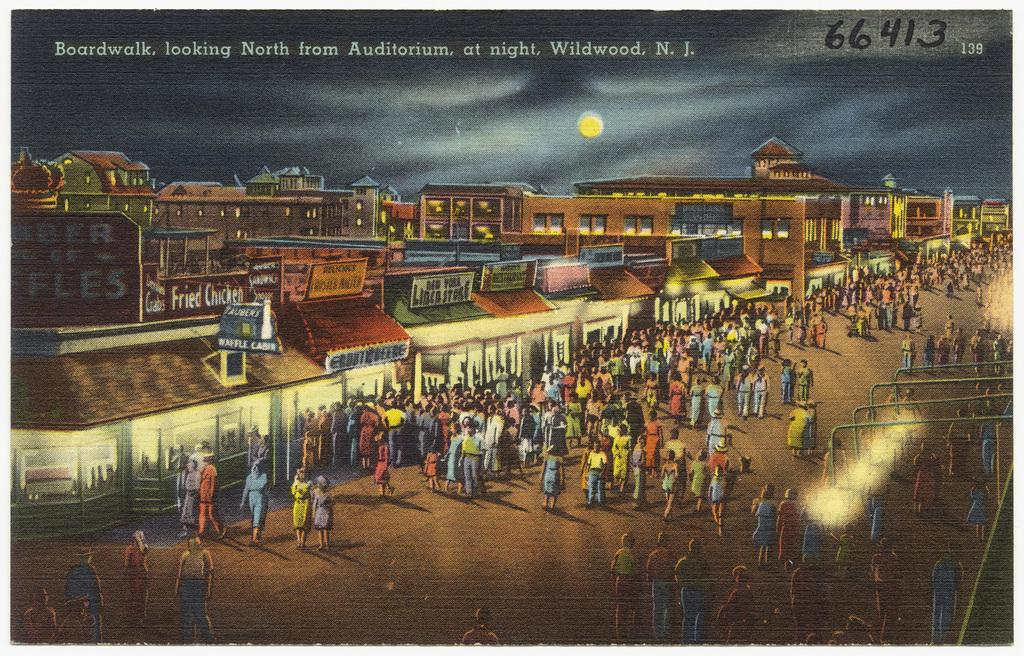<image>
Summarize the visual content of the image. Postcard that says: Boardwalk, Looking North from Auditorium at night. Wildwood N.J. # 66413 139. 